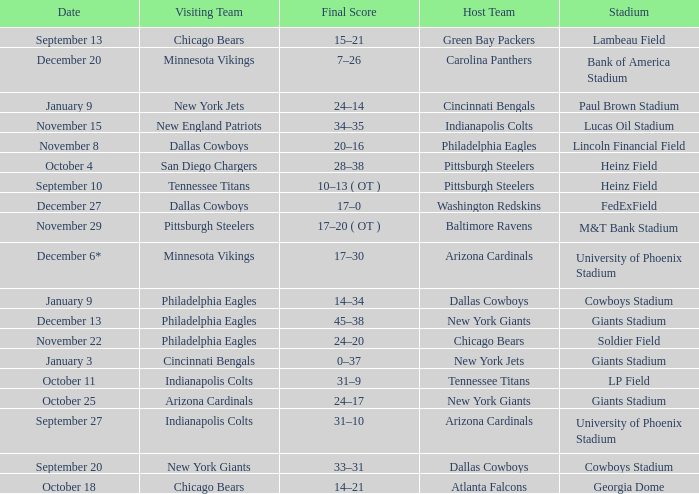I want to know the final score for december 27 17–0. 